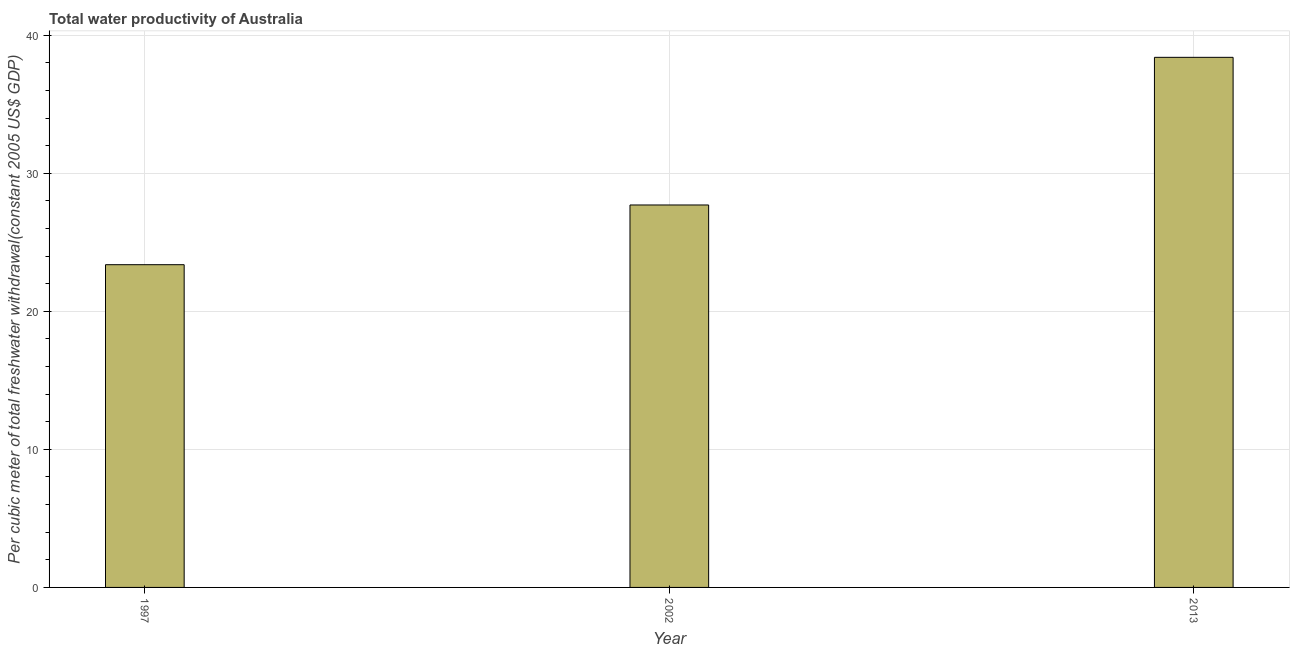Does the graph contain grids?
Provide a succinct answer. Yes. What is the title of the graph?
Provide a short and direct response. Total water productivity of Australia. What is the label or title of the X-axis?
Your answer should be compact. Year. What is the label or title of the Y-axis?
Offer a terse response. Per cubic meter of total freshwater withdrawal(constant 2005 US$ GDP). What is the total water productivity in 2002?
Provide a short and direct response. 27.7. Across all years, what is the maximum total water productivity?
Offer a terse response. 38.4. Across all years, what is the minimum total water productivity?
Your answer should be very brief. 23.38. What is the sum of the total water productivity?
Offer a terse response. 89.48. What is the difference between the total water productivity in 1997 and 2002?
Offer a terse response. -4.33. What is the average total water productivity per year?
Your answer should be compact. 29.83. What is the median total water productivity?
Offer a very short reply. 27.7. What is the ratio of the total water productivity in 1997 to that in 2013?
Your response must be concise. 0.61. Is the difference between the total water productivity in 2002 and 2013 greater than the difference between any two years?
Ensure brevity in your answer.  No. What is the difference between the highest and the second highest total water productivity?
Offer a terse response. 10.7. Is the sum of the total water productivity in 1997 and 2002 greater than the maximum total water productivity across all years?
Your answer should be compact. Yes. What is the difference between the highest and the lowest total water productivity?
Provide a succinct answer. 15.02. In how many years, is the total water productivity greater than the average total water productivity taken over all years?
Offer a very short reply. 1. Are all the bars in the graph horizontal?
Ensure brevity in your answer.  No. What is the difference between two consecutive major ticks on the Y-axis?
Your answer should be compact. 10. Are the values on the major ticks of Y-axis written in scientific E-notation?
Your answer should be very brief. No. What is the Per cubic meter of total freshwater withdrawal(constant 2005 US$ GDP) in 1997?
Provide a succinct answer. 23.38. What is the Per cubic meter of total freshwater withdrawal(constant 2005 US$ GDP) of 2002?
Ensure brevity in your answer.  27.7. What is the Per cubic meter of total freshwater withdrawal(constant 2005 US$ GDP) in 2013?
Your response must be concise. 38.4. What is the difference between the Per cubic meter of total freshwater withdrawal(constant 2005 US$ GDP) in 1997 and 2002?
Your answer should be very brief. -4.33. What is the difference between the Per cubic meter of total freshwater withdrawal(constant 2005 US$ GDP) in 1997 and 2013?
Keep it short and to the point. -15.02. What is the difference between the Per cubic meter of total freshwater withdrawal(constant 2005 US$ GDP) in 2002 and 2013?
Provide a succinct answer. -10.7. What is the ratio of the Per cubic meter of total freshwater withdrawal(constant 2005 US$ GDP) in 1997 to that in 2002?
Your answer should be very brief. 0.84. What is the ratio of the Per cubic meter of total freshwater withdrawal(constant 2005 US$ GDP) in 1997 to that in 2013?
Provide a succinct answer. 0.61. What is the ratio of the Per cubic meter of total freshwater withdrawal(constant 2005 US$ GDP) in 2002 to that in 2013?
Give a very brief answer. 0.72. 